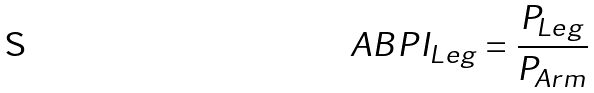Convert formula to latex. <formula><loc_0><loc_0><loc_500><loc_500>A B P I _ { L e g } = \frac { P _ { L e g } } { P _ { A r m } }</formula> 